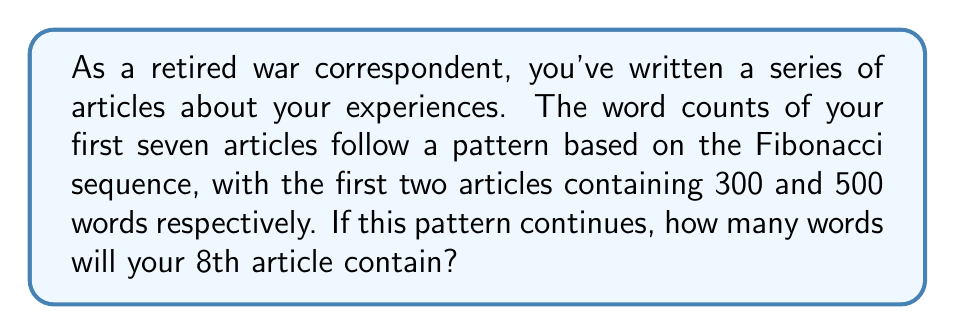Teach me how to tackle this problem. Let's approach this step-by-step:

1) First, recall the Fibonacci sequence: Each number is the sum of the two preceding ones.

2) We're given that the first two articles have 300 and 500 words. Let's list out the word counts for the first 7 articles:

   Article 1: 300 words
   Article 2: 500 words
   Article 3: 300 + 500 = 800 words
   Article 4: 500 + 800 = 1300 words
   Article 5: 800 + 1300 = 2100 words
   Article 6: 1300 + 2100 = 3400 words
   Article 7: 2100 + 3400 = 5500 words

3) To find the word count for the 8th article, we need to add the word counts of the 6th and 7th articles:

   Article 8: 3400 + 5500 = 8900 words

4) We can verify this follows the Fibonacci pattern:

   $$F_n = F_{n-1} + F_{n-2}$$

   Where $F_n$ represents the nth term in the sequence.

5) Indeed, 8900 = 5500 + 3400, confirming the pattern holds.

Therefore, the 8th article in the series will contain 8900 words.
Answer: 8900 words 